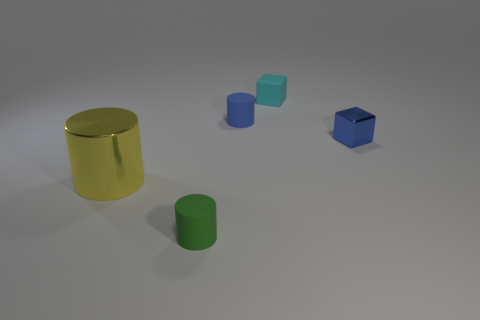Can you describe the lighting source and its effect on the objects? The lighting in this image appears to be coming from above, casting soft shadows below and to the right of the objects, which suggests a single overhead diffused light source. 